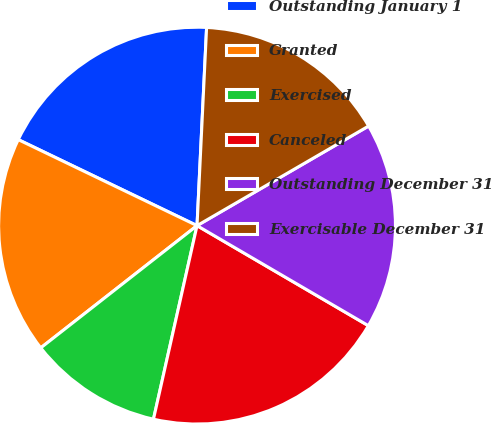<chart> <loc_0><loc_0><loc_500><loc_500><pie_chart><fcel>Outstanding January 1<fcel>Granted<fcel>Exercised<fcel>Canceled<fcel>Outstanding December 31<fcel>Exercisable December 31<nl><fcel>18.63%<fcel>17.7%<fcel>10.91%<fcel>20.11%<fcel>16.78%<fcel>15.86%<nl></chart> 